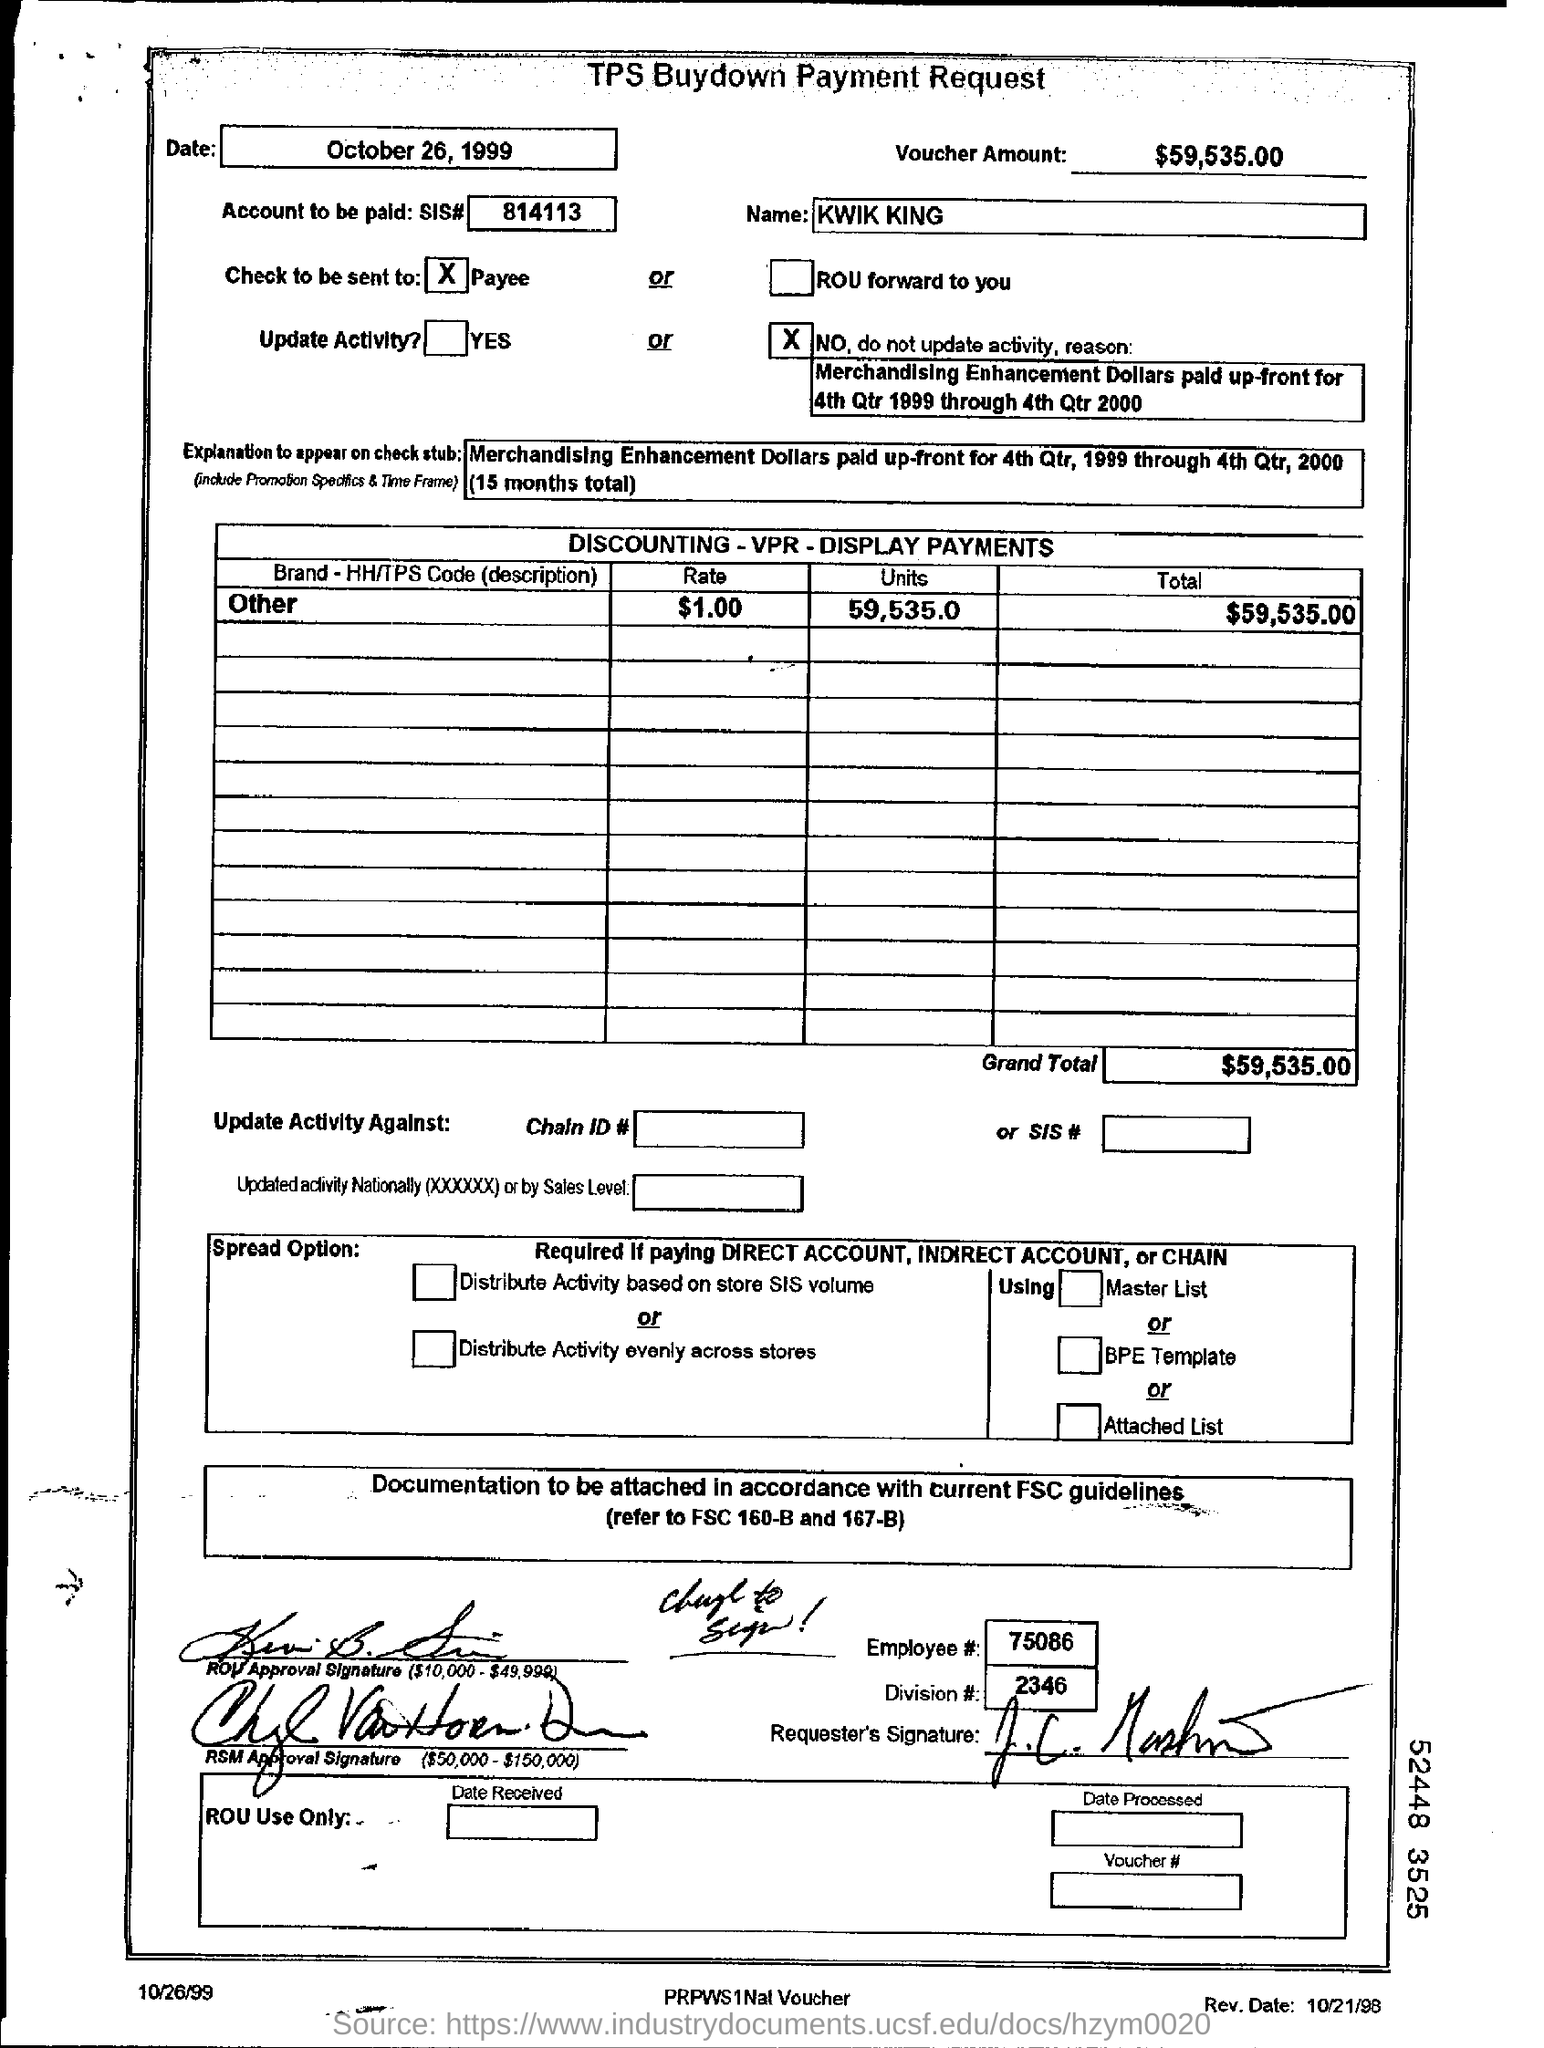Specify some key components in this picture. The voucher contains $59,535.00 in total amount. According to the data provided, the brand 'HH' had a total of 59,535 units in the given time period, with a TPS Code (Description) for others. The rate for the brand is $1.00 per HH/TPS Code (description) for others. The total amount for the brand, including the HH/TPS Code (description) for others, is $59,535.00. 